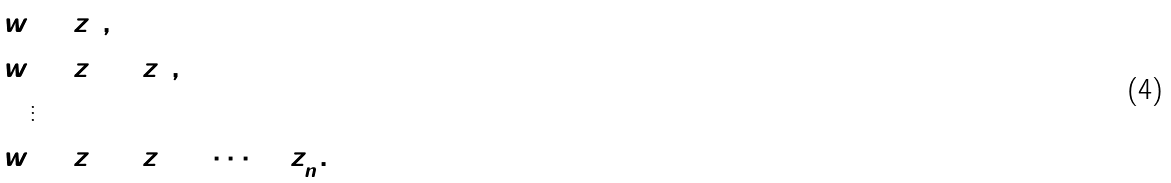<formula> <loc_0><loc_0><loc_500><loc_500>w & = \bar { z } _ { 1 } ^ { 2 } , \\ w & = \bar { z } _ { 1 } ^ { 2 } + \bar { z } _ { 2 } ^ { 2 } , \\ & \vdots \\ w & = \bar { z } _ { 1 } ^ { 2 } + \bar { z } _ { 2 } ^ { 2 } + \dots + \bar { z } _ { n } ^ { 2 } .</formula> 